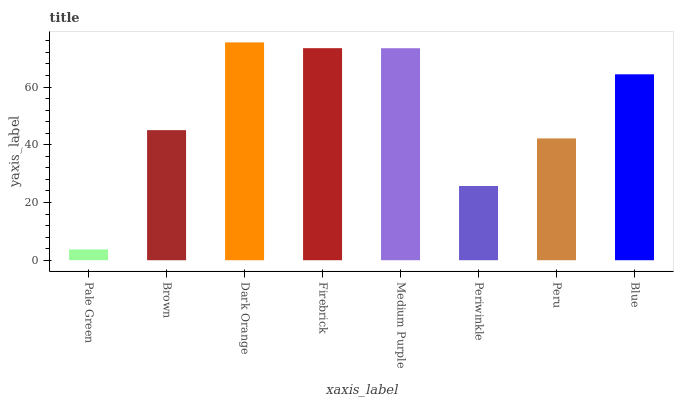Is Pale Green the minimum?
Answer yes or no. Yes. Is Dark Orange the maximum?
Answer yes or no. Yes. Is Brown the minimum?
Answer yes or no. No. Is Brown the maximum?
Answer yes or no. No. Is Brown greater than Pale Green?
Answer yes or no. Yes. Is Pale Green less than Brown?
Answer yes or no. Yes. Is Pale Green greater than Brown?
Answer yes or no. No. Is Brown less than Pale Green?
Answer yes or no. No. Is Blue the high median?
Answer yes or no. Yes. Is Brown the low median?
Answer yes or no. Yes. Is Periwinkle the high median?
Answer yes or no. No. Is Dark Orange the low median?
Answer yes or no. No. 